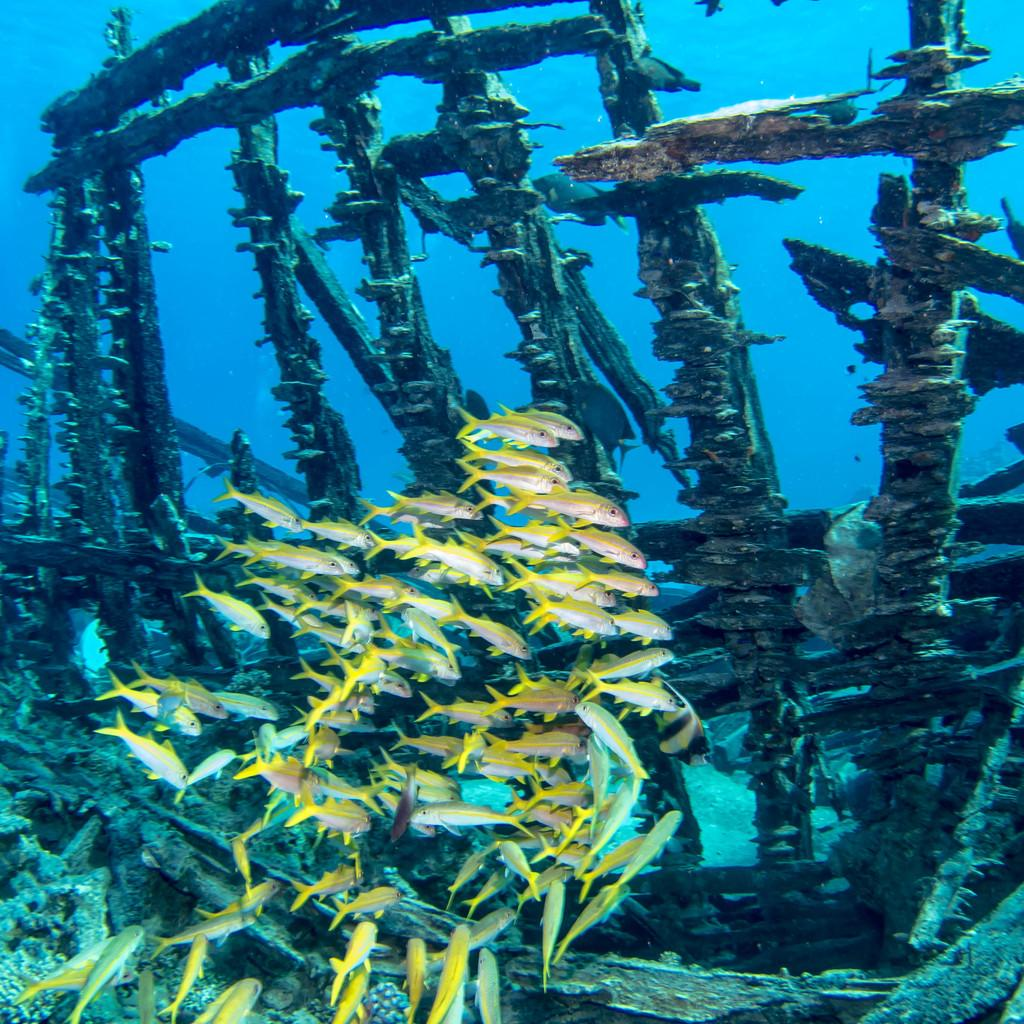What type of animals can be seen in the image? There are many fishes in the image. What color are the tails of the fishes? The fishes have yellow color tails. Where are the fishes located in the image? The fishes are swimming in the sea. What can be seen in the water besides the fishes? There is a wooden frame in the water. How much money can be seen in the image? There is no money present in the image; it features fishes swimming in the sea and a wooden frame in the water. What type of berry is being used as a decoration in the image? There are no berries present in the image. 